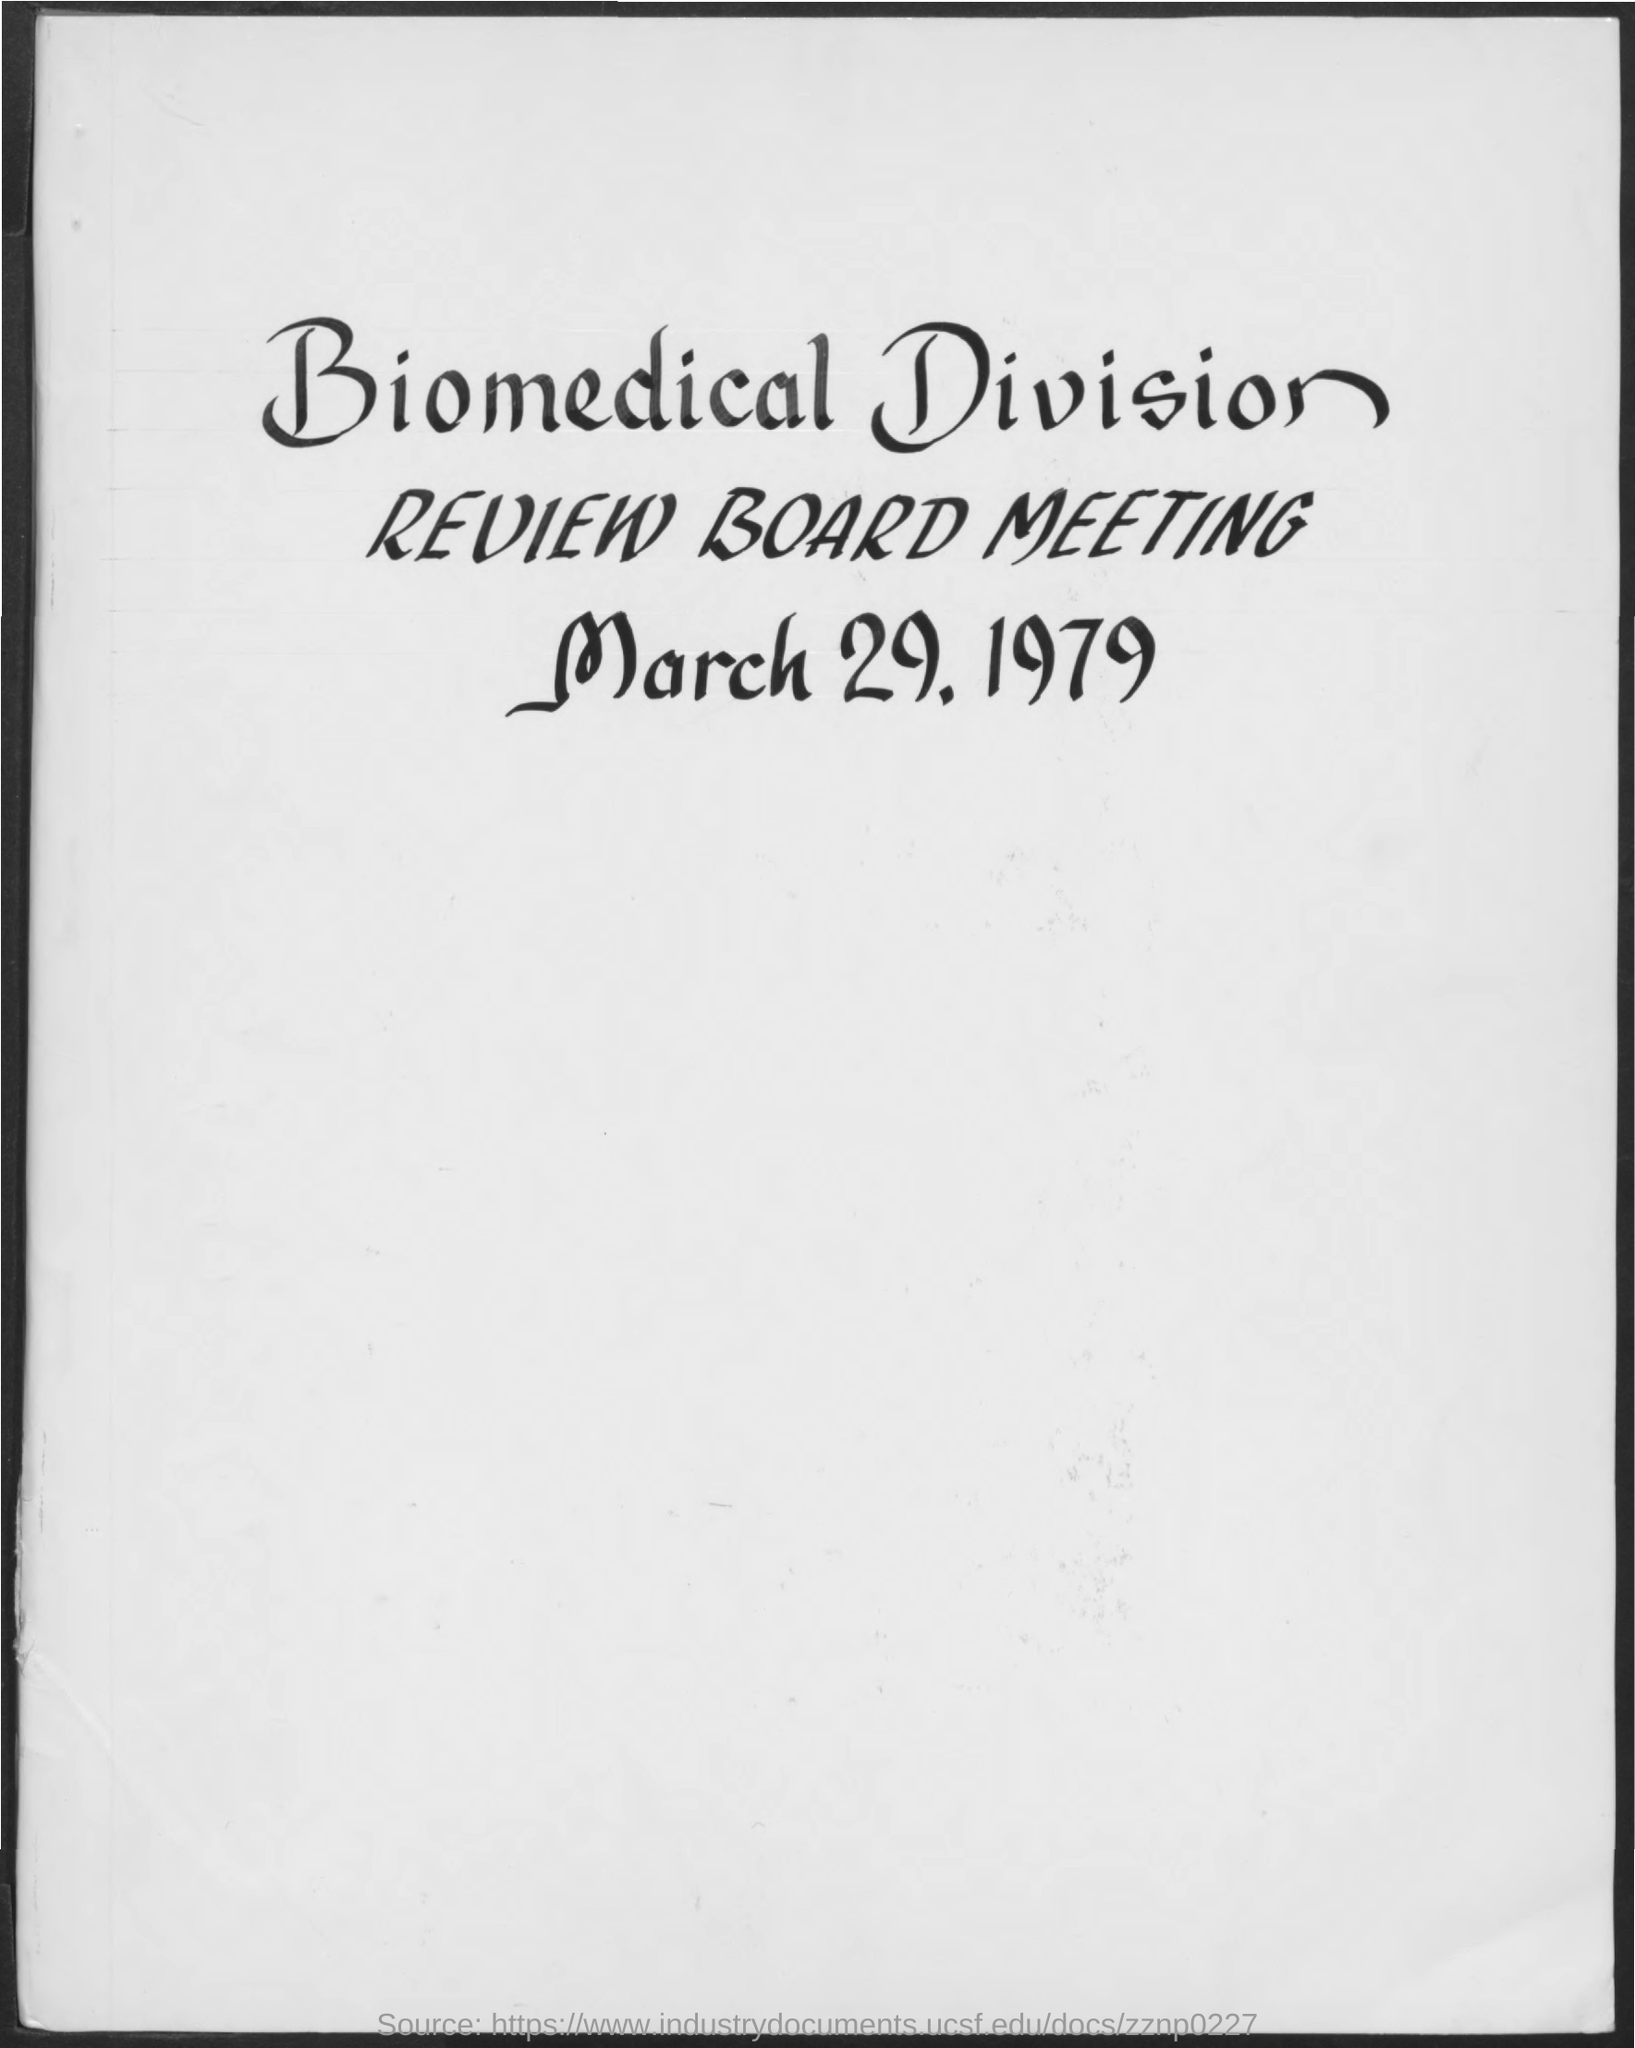Point out several critical features in this image. The Biomedical Division Review Board Meeting is scheduled to be held on March 29, 1979. 